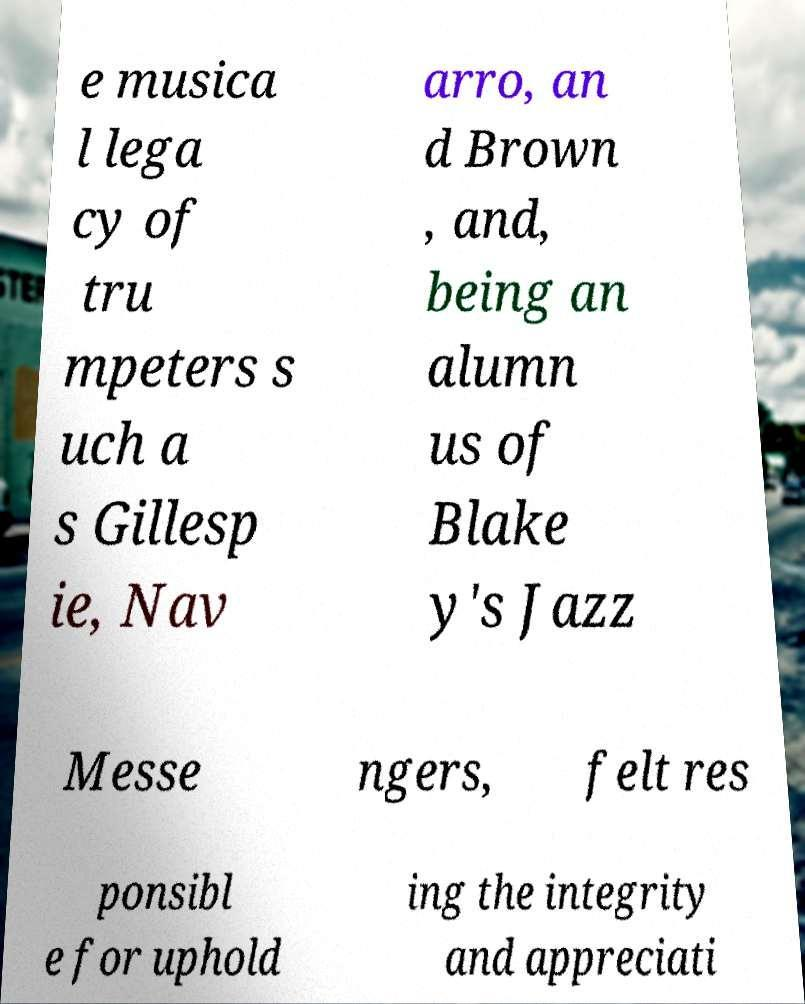I need the written content from this picture converted into text. Can you do that? e musica l lega cy of tru mpeters s uch a s Gillesp ie, Nav arro, an d Brown , and, being an alumn us of Blake y's Jazz Messe ngers, felt res ponsibl e for uphold ing the integrity and appreciati 